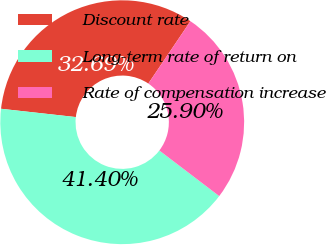<chart> <loc_0><loc_0><loc_500><loc_500><pie_chart><fcel>Discount rate<fcel>Long-term rate of return on<fcel>Rate of compensation increase<nl><fcel>32.69%<fcel>41.4%<fcel>25.9%<nl></chart> 